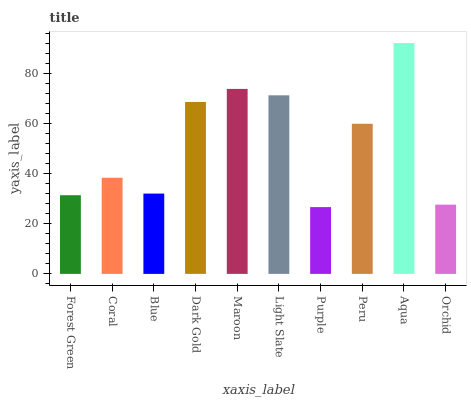Is Coral the minimum?
Answer yes or no. No. Is Coral the maximum?
Answer yes or no. No. Is Coral greater than Forest Green?
Answer yes or no. Yes. Is Forest Green less than Coral?
Answer yes or no. Yes. Is Forest Green greater than Coral?
Answer yes or no. No. Is Coral less than Forest Green?
Answer yes or no. No. Is Peru the high median?
Answer yes or no. Yes. Is Coral the low median?
Answer yes or no. Yes. Is Maroon the high median?
Answer yes or no. No. Is Light Slate the low median?
Answer yes or no. No. 